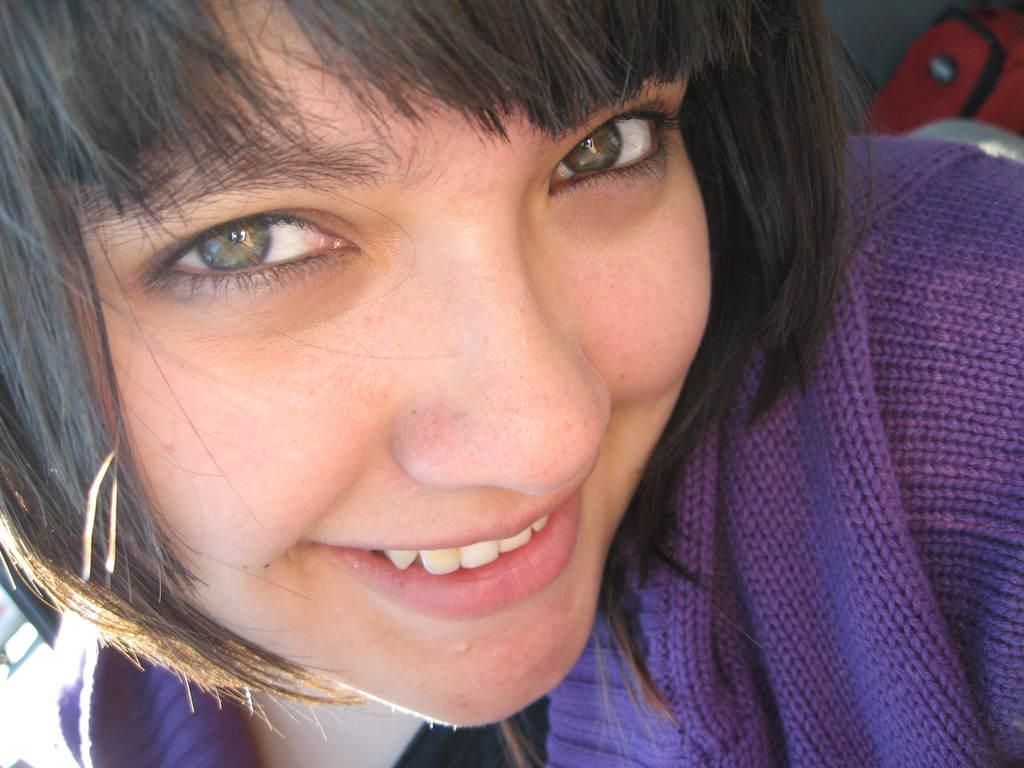Who or what is the main subject in the image? There is a person in the image. What is the person wearing? The person is wearing a purple dress. Can you describe any other objects or colors in the image? There is a red color bag in the background of the image. What type of fact can be heard coming from the person in the image? There is no indication in the image that the person is speaking or making any sounds, so it's not possible to determine what, if any, facts might be heard. 